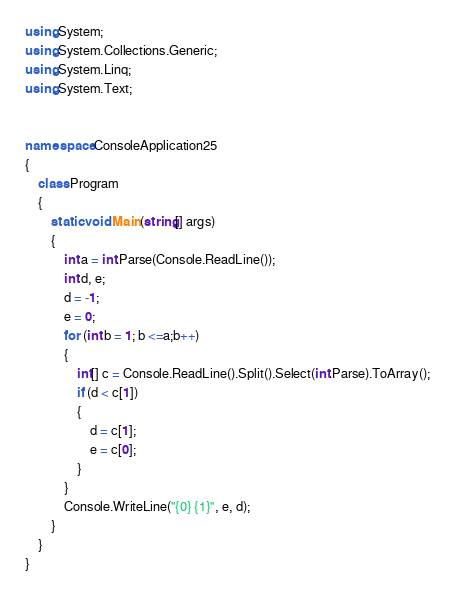<code> <loc_0><loc_0><loc_500><loc_500><_C#_>using System;
using System.Collections.Generic;
using System.Linq;
using System.Text;


namespace ConsoleApplication25
{
    class Program
    {
        static void Main(string[] args)
        {
            int a = int.Parse(Console.ReadLine());
            int d, e;
            d = -1;
            e = 0;
            for (int b = 1; b <=a;b++)
            {
                int[] c = Console.ReadLine().Split().Select(int.Parse).ToArray();
                if (d < c[1])
                {
                    d = c[1];
                    e = c[0];
                }
            }
            Console.WriteLine("{0} {1}", e, d);
        }
    }
}</code> 